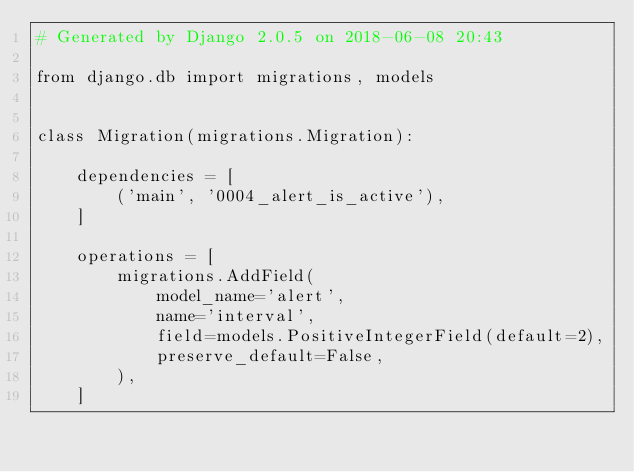<code> <loc_0><loc_0><loc_500><loc_500><_Python_># Generated by Django 2.0.5 on 2018-06-08 20:43

from django.db import migrations, models


class Migration(migrations.Migration):

    dependencies = [
        ('main', '0004_alert_is_active'),
    ]

    operations = [
        migrations.AddField(
            model_name='alert',
            name='interval',
            field=models.PositiveIntegerField(default=2),
            preserve_default=False,
        ),
    ]
</code> 